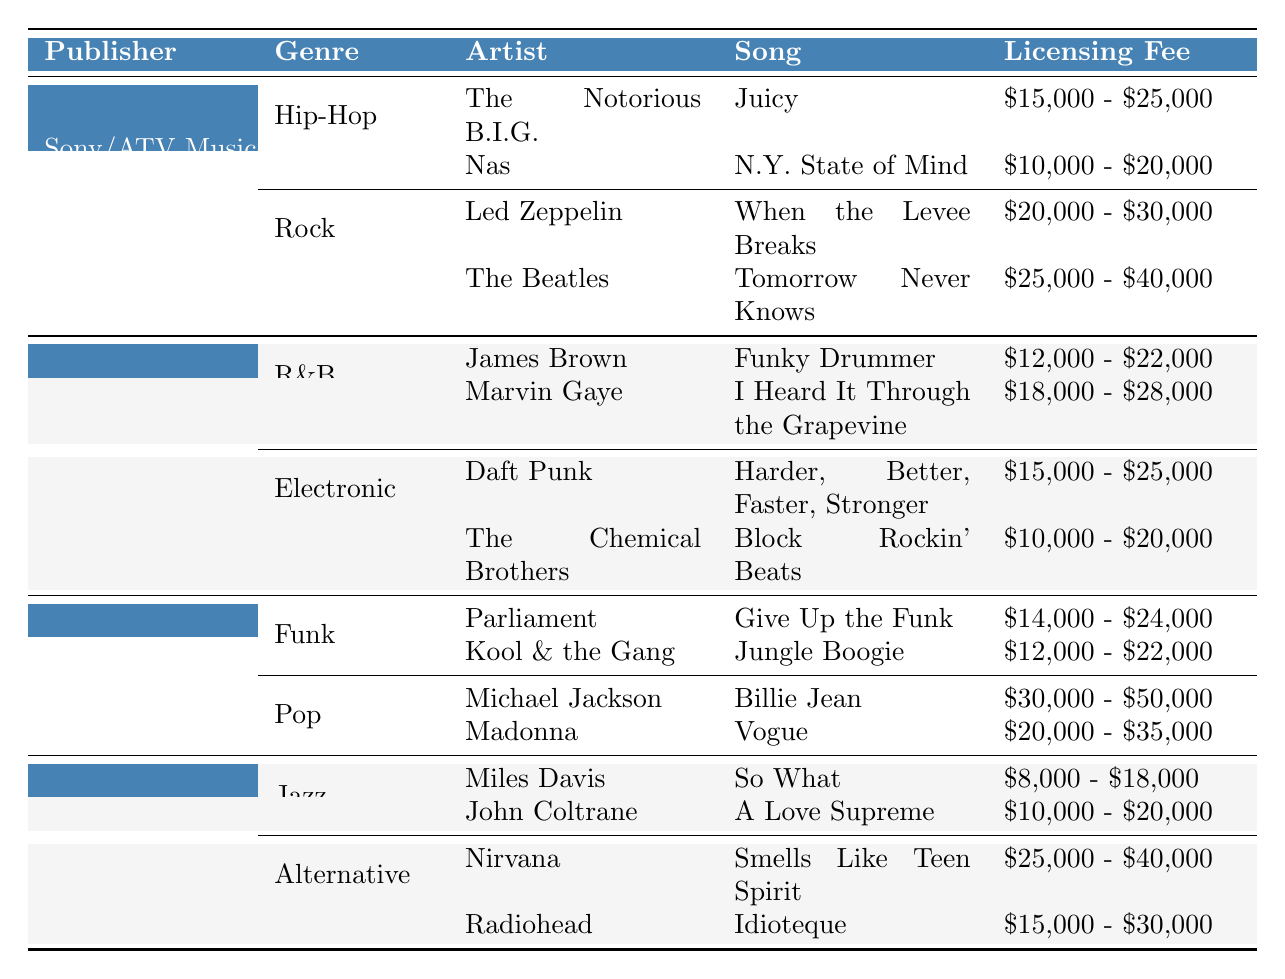What is the licensing fee range for "Billie Jean" by Michael Jackson? The table shows that "Billie Jean" is licensed from Warner Chappell Music with a fee range of $30,000 - $50,000.
Answer: $30,000 - $50,000 Which publisher offers the highest licensing fee for their samples? From the table, Warner Chappell Music lists a maximum fee of $50,000 for "Billie Jean," which is the highest among all publishers.
Answer: Warner Chappell Music What is the average licensing fee range for the samples in the Hip-Hop genre? The fees for Hip-Hop samples are $15,000 - $25,000 for "Juicy" and $10,000 - $20,000 for "N.Y. State of Mind." To find the average, take the midpoints of both ranges: (20,000 + 15,000) / 2 = $17,500 and (25,000 + 10,000) / 2 = $17,500. The average of the midpoints is $17,500.
Answer: $17,500 Is "I Heard It Through the Grapevine" by Marvin Gaye cheaper to license than "So What" by Miles Davis? The licensing fee for "I Heard It Through the Grapevine" is $18,000 - $28,000, and for "So What," it's $8,000 - $18,000. The minimum of "I Heard It Through the Grapevine" is higher than the maximum of "So What." Therefore, the statement is true.
Answer: Yes What are the total licensing fees for all the samples listed under Warner Chappell Music? For Funk, the fees are $14,000 - $24,000 and $12,000 - $22,000; for Pop, they are $30,000 - $50,000 and $20,000 - $35,000. Calculating the total, the minimum is $14,000 + $12,000 + $30,000 + $20,000 = $76,000 and the maximum is $24,000 + $22,000 + $50,000 + $35,000 = $131,000. Thus, the total licensing fees range is $76,000 - $131,000.
Answer: $76,000 - $131,000 Which genre has the most samples listed in the table? By examining the table, Hip-Hop and Rock under Sony/ATV, R&B and Electronic under Universal Music Publishing, Funk and Pop under Warner Chappell, and Jazz and Alternative under Kobalt Music; each genre has two samples listed, showing that no genre has more samples listed than another.
Answer: None; all genres have two samples What is the difference in the maximum licensing fees between the highest fee in Rock and the lowest in Jazz? The highest fee in Rock is $40,000 (for "Tomorrow Never Knows") and the lowest in Jazz is $8,000 (for "So What"). The difference is $40,000 - $8,000 = $32,000.
Answer: $32,000 